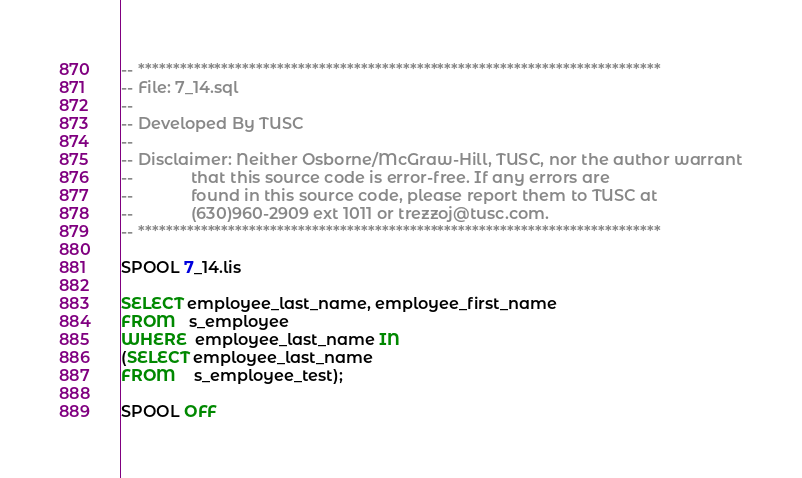<code> <loc_0><loc_0><loc_500><loc_500><_SQL_>-- ***************************************************************************
-- File: 7_14.sql
--
-- Developed By TUSC
--
-- Disclaimer: Neither Osborne/McGraw-Hill, TUSC, nor the author warrant
--             that this source code is error-free. If any errors are
--             found in this source code, please report them to TUSC at
--             (630)960-2909 ext 1011 or trezzoj@tusc.com.
-- ***************************************************************************

SPOOL 7_14.lis

SELECT employee_last_name, employee_first_name
FROM   s_employee
WHERE  employee_last_name IN
(SELECT employee_last_name
FROM    s_employee_test);

SPOOL OFF
</code> 